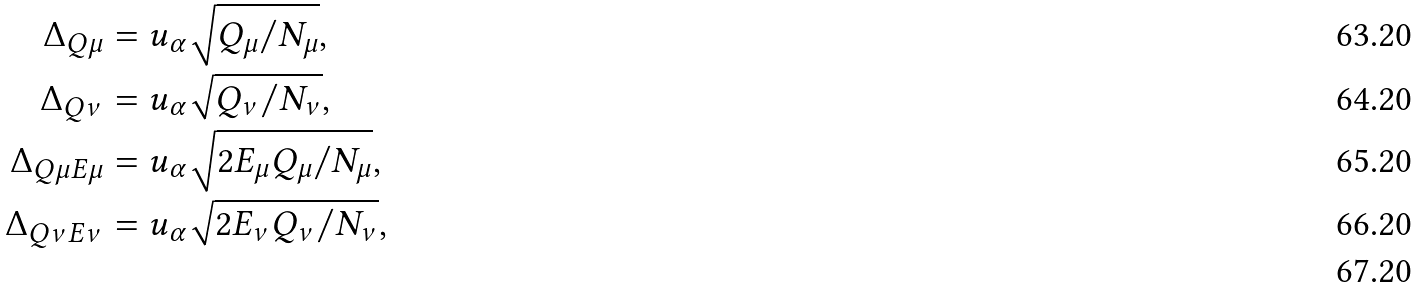Convert formula to latex. <formula><loc_0><loc_0><loc_500><loc_500>\Delta _ { Q \mu } & = u _ { \alpha } \sqrt { Q _ { \mu } / N _ { \mu } } , \\ \Delta _ { Q \nu } & = u _ { \alpha } \sqrt { Q _ { \nu } / N _ { \nu } } , \\ \Delta _ { Q \mu E \mu } & = u _ { \alpha } \sqrt { 2 E _ { \mu } Q _ { \mu } / N _ { \mu } } , \\ \Delta _ { Q \nu E \nu } & = u _ { \alpha } \sqrt { 2 E _ { \nu } Q _ { \nu } / N _ { \nu } } , \\</formula> 